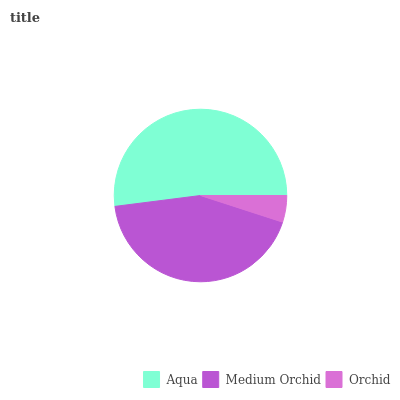Is Orchid the minimum?
Answer yes or no. Yes. Is Aqua the maximum?
Answer yes or no. Yes. Is Medium Orchid the minimum?
Answer yes or no. No. Is Medium Orchid the maximum?
Answer yes or no. No. Is Aqua greater than Medium Orchid?
Answer yes or no. Yes. Is Medium Orchid less than Aqua?
Answer yes or no. Yes. Is Medium Orchid greater than Aqua?
Answer yes or no. No. Is Aqua less than Medium Orchid?
Answer yes or no. No. Is Medium Orchid the high median?
Answer yes or no. Yes. Is Medium Orchid the low median?
Answer yes or no. Yes. Is Aqua the high median?
Answer yes or no. No. Is Aqua the low median?
Answer yes or no. No. 